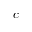<formula> <loc_0><loc_0><loc_500><loc_500>c</formula> 